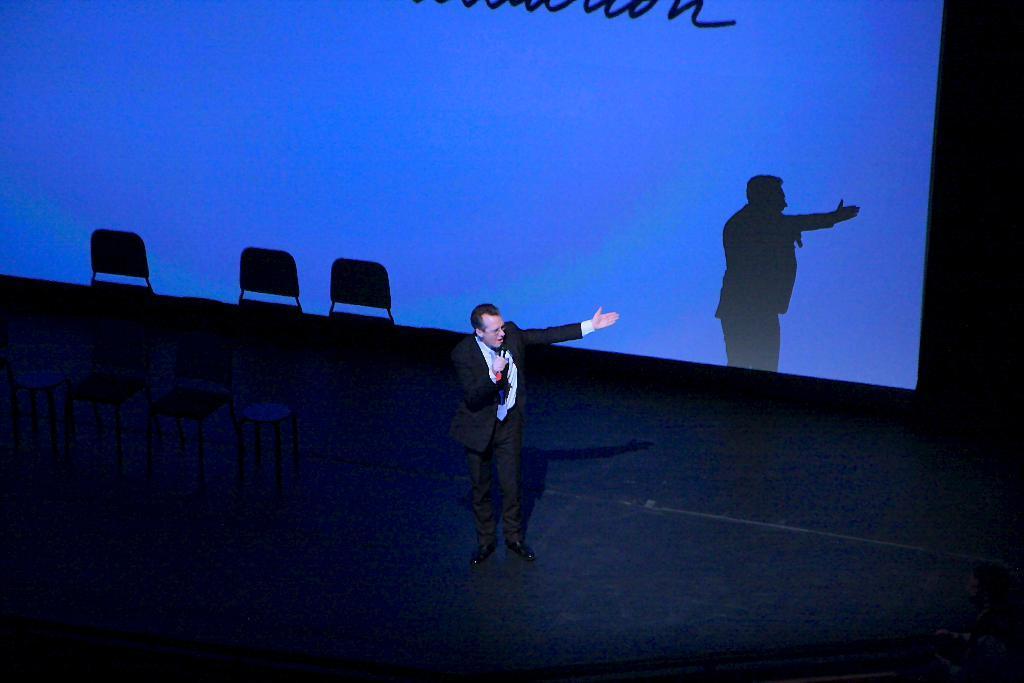Can you describe this image briefly? In the image there is a person he is speaking something, behind him there are few empty chairs and in the background there is a presentation screen, it is displaying blue light with some text. 